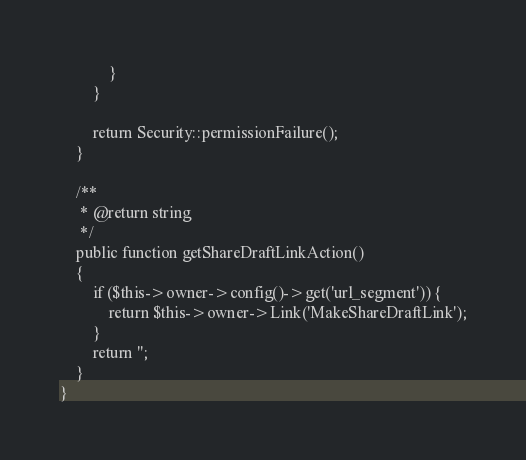Convert code to text. <code><loc_0><loc_0><loc_500><loc_500><_PHP_>            }
        }

        return Security::permissionFailure();
    }

    /**
     * @return string
     */
    public function getShareDraftLinkAction()
    {
        if ($this->owner->config()->get('url_segment')) {
            return $this->owner->Link('MakeShareDraftLink');
        }
        return '';
    }
}
</code> 